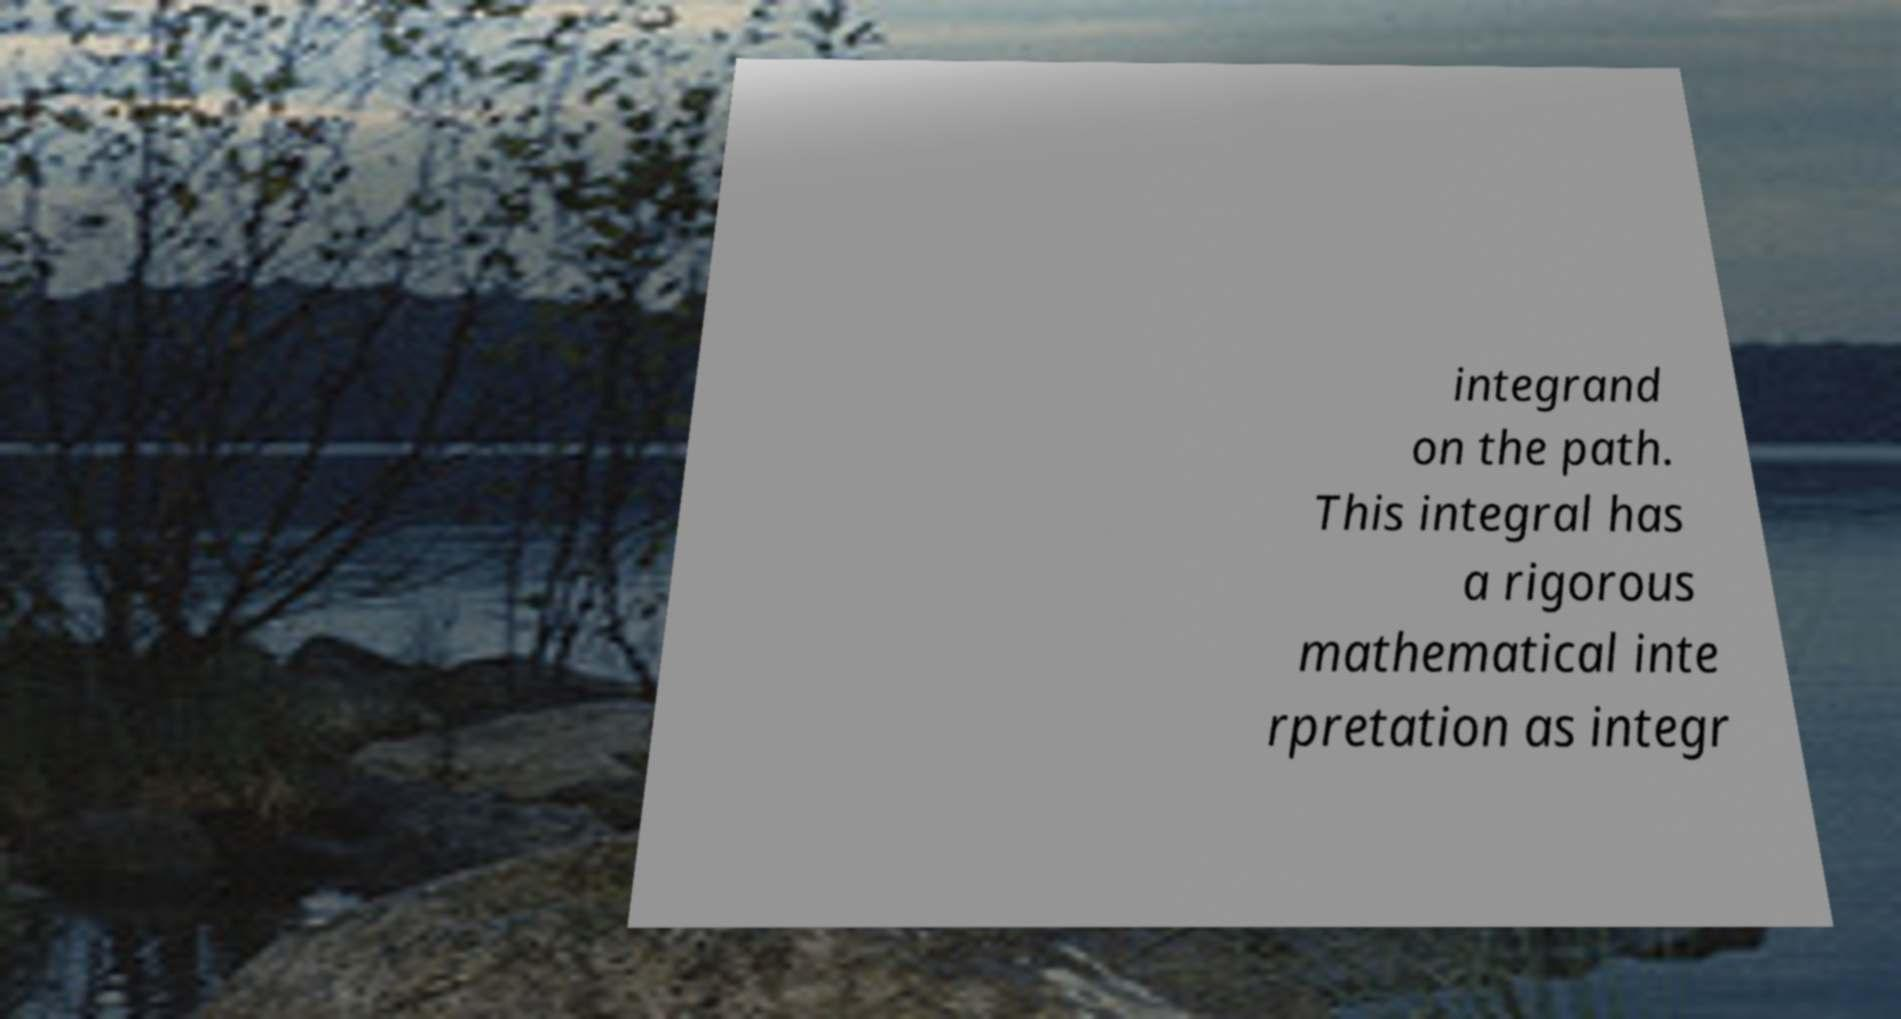Could you extract and type out the text from this image? integrand on the path. This integral has a rigorous mathematical inte rpretation as integr 